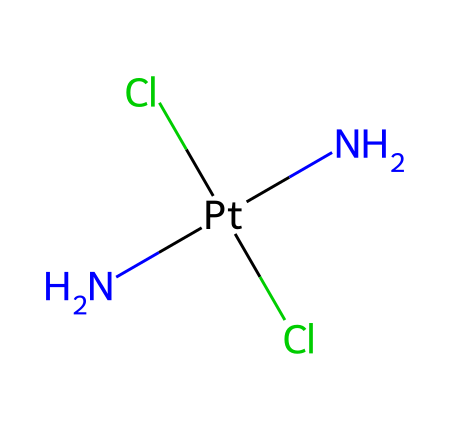What is the central metal atom in this compound? The central metal atom can be identified by the element symbol that is not surrounded by other elements in the coordination complex. In this case, 'Pt' represents platinum, which is the central metal atom in cisplatin.
Answer: platinum How many chlorine atoms are present in this structure? To determine the number of chlorine atoms, we can count the occurrences of the element symbol 'Cl' in the structure. There are two 'Cl' present, indicating that there are two chlorine atoms in the compound.
Answer: 2 What is the oxidation state of platinum in this compound? The oxidation state of platinum can be inferred by considering the charges of the ligands attached to it. Each chlorine atom has a charge of -1, and since there are two, they contribute a total of -2. The two amine groups, being neutral, do not contribute any charge. Therefore, in order for the compound to be neutral, the platinum must have a +2 oxidation state to offset the -2 from chlorine.
Answer: +2 Which type of coordination geometry does this complex likely exhibit? The coordination number for this complex can be derived from the number of ligand atoms bonded to the metal center. Here, there are four ligands: two amines and two chlorides. This typically corresponds to a square planar geometry in coordination chemistry, which is common for cisplatin.
Answer: square planar What type of ligands are present in this compound? The ligands can be identified by examining the groups attached to the central metal atom. In the case of cisplatin, there are two ammonia (amine) ligands and two chloride ligands. Amine ligands are classified as neutral, while chloride ligands are anionic.
Answer: amines and chlorides How does this compound interact with DNA? The mechanism of interaction can be understood by observing the ligands and metal center. The cis positioning of the chlorine ligands allows for the formation of a covalent bond with DNA, primarily at the N7 position of guanine bases, leading to cross-linking which inhibits DNA replication.
Answer: cross-linking What is the primary application of this compound in medicine? The primary application of this compound can be determined by understanding the therapeutic uses of cisplatin, particularly noted in cancer treatments. It is widely used for treating various types of cancers, including gastrointestinal cancer, by inducing apoptosis in cancer cells.
Answer: cancer treatment 